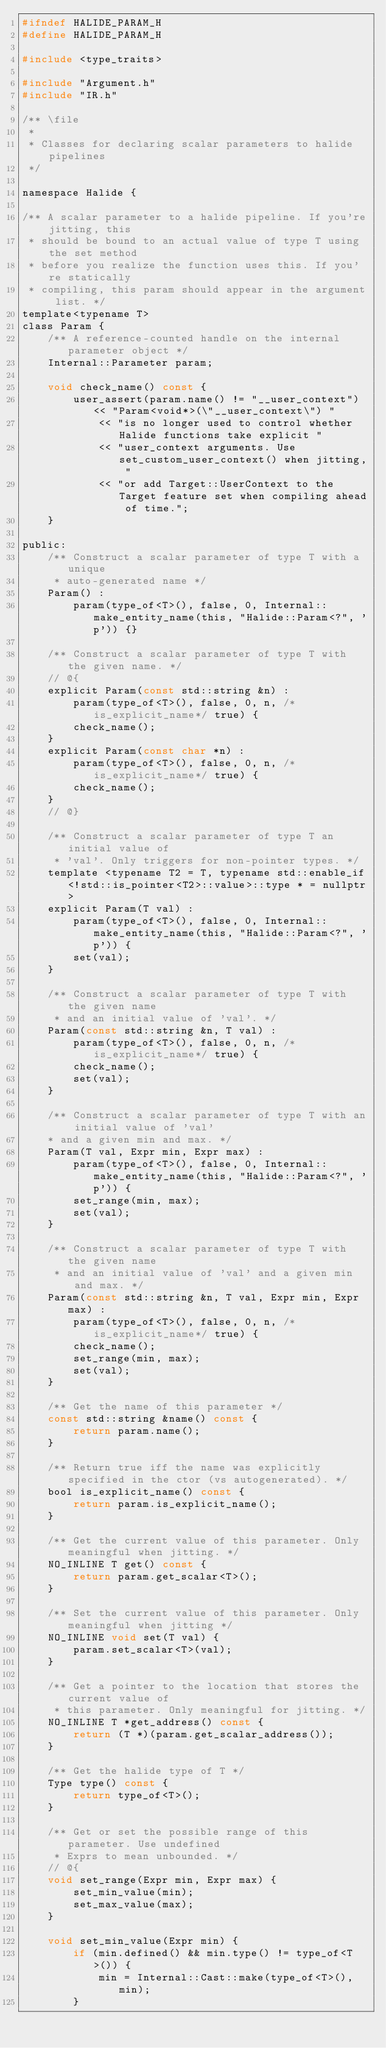<code> <loc_0><loc_0><loc_500><loc_500><_C_>#ifndef HALIDE_PARAM_H
#define HALIDE_PARAM_H

#include <type_traits>

#include "Argument.h"
#include "IR.h"

/** \file
 *
 * Classes for declaring scalar parameters to halide pipelines
 */

namespace Halide {

/** A scalar parameter to a halide pipeline. If you're jitting, this
 * should be bound to an actual value of type T using the set method
 * before you realize the function uses this. If you're statically
 * compiling, this param should appear in the argument list. */
template<typename T>
class Param {
    /** A reference-counted handle on the internal parameter object */
    Internal::Parameter param;

    void check_name() const {
        user_assert(param.name() != "__user_context") << "Param<void*>(\"__user_context\") "
            << "is no longer used to control whether Halide functions take explicit "
            << "user_context arguments. Use set_custom_user_context() when jitting, "
            << "or add Target::UserContext to the Target feature set when compiling ahead of time.";
    }

public:
    /** Construct a scalar parameter of type T with a unique
     * auto-generated name */
    Param() :
        param(type_of<T>(), false, 0, Internal::make_entity_name(this, "Halide::Param<?", 'p')) {}

    /** Construct a scalar parameter of type T with the given name. */
    // @{
    explicit Param(const std::string &n) :
        param(type_of<T>(), false, 0, n, /*is_explicit_name*/ true) {
        check_name();
    }
    explicit Param(const char *n) :
        param(type_of<T>(), false, 0, n, /*is_explicit_name*/ true) {
        check_name();
    }
    // @}

    /** Construct a scalar parameter of type T an initial value of
     * 'val'. Only triggers for non-pointer types. */
    template <typename T2 = T, typename std::enable_if<!std::is_pointer<T2>::value>::type * = nullptr>
    explicit Param(T val) :
        param(type_of<T>(), false, 0, Internal::make_entity_name(this, "Halide::Param<?", 'p')) {
        set(val);
    }

    /** Construct a scalar parameter of type T with the given name
     * and an initial value of 'val'. */
    Param(const std::string &n, T val) :
        param(type_of<T>(), false, 0, n, /*is_explicit_name*/ true) {
        check_name();
        set(val);
    }

    /** Construct a scalar parameter of type T with an initial value of 'val'
    * and a given min and max. */
    Param(T val, Expr min, Expr max) :
        param(type_of<T>(), false, 0, Internal::make_entity_name(this, "Halide::Param<?", 'p')) {
        set_range(min, max);
        set(val);
    }

    /** Construct a scalar parameter of type T with the given name
     * and an initial value of 'val' and a given min and max. */
    Param(const std::string &n, T val, Expr min, Expr max) :
        param(type_of<T>(), false, 0, n, /*is_explicit_name*/ true) {
        check_name();
        set_range(min, max);
        set(val);
    }

    /** Get the name of this parameter */
    const std::string &name() const {
        return param.name();
    }

    /** Return true iff the name was explicitly specified in the ctor (vs autogenerated). */
    bool is_explicit_name() const {
        return param.is_explicit_name();
    }

    /** Get the current value of this parameter. Only meaningful when jitting. */
    NO_INLINE T get() const {
        return param.get_scalar<T>();
    }

    /** Set the current value of this parameter. Only meaningful when jitting */
    NO_INLINE void set(T val) {
        param.set_scalar<T>(val);
    }

    /** Get a pointer to the location that stores the current value of
     * this parameter. Only meaningful for jitting. */
    NO_INLINE T *get_address() const {
        return (T *)(param.get_scalar_address());
    }

    /** Get the halide type of T */
    Type type() const {
        return type_of<T>();
    }

    /** Get or set the possible range of this parameter. Use undefined
     * Exprs to mean unbounded. */
    // @{
    void set_range(Expr min, Expr max) {
        set_min_value(min);
        set_max_value(max);
    }

    void set_min_value(Expr min) {
        if (min.defined() && min.type() != type_of<T>()) {
            min = Internal::Cast::make(type_of<T>(), min);
        }</code> 